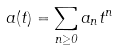<formula> <loc_0><loc_0><loc_500><loc_500>a ( t ) = \sum _ { n \geq 0 } a _ { n } t ^ { n }</formula> 